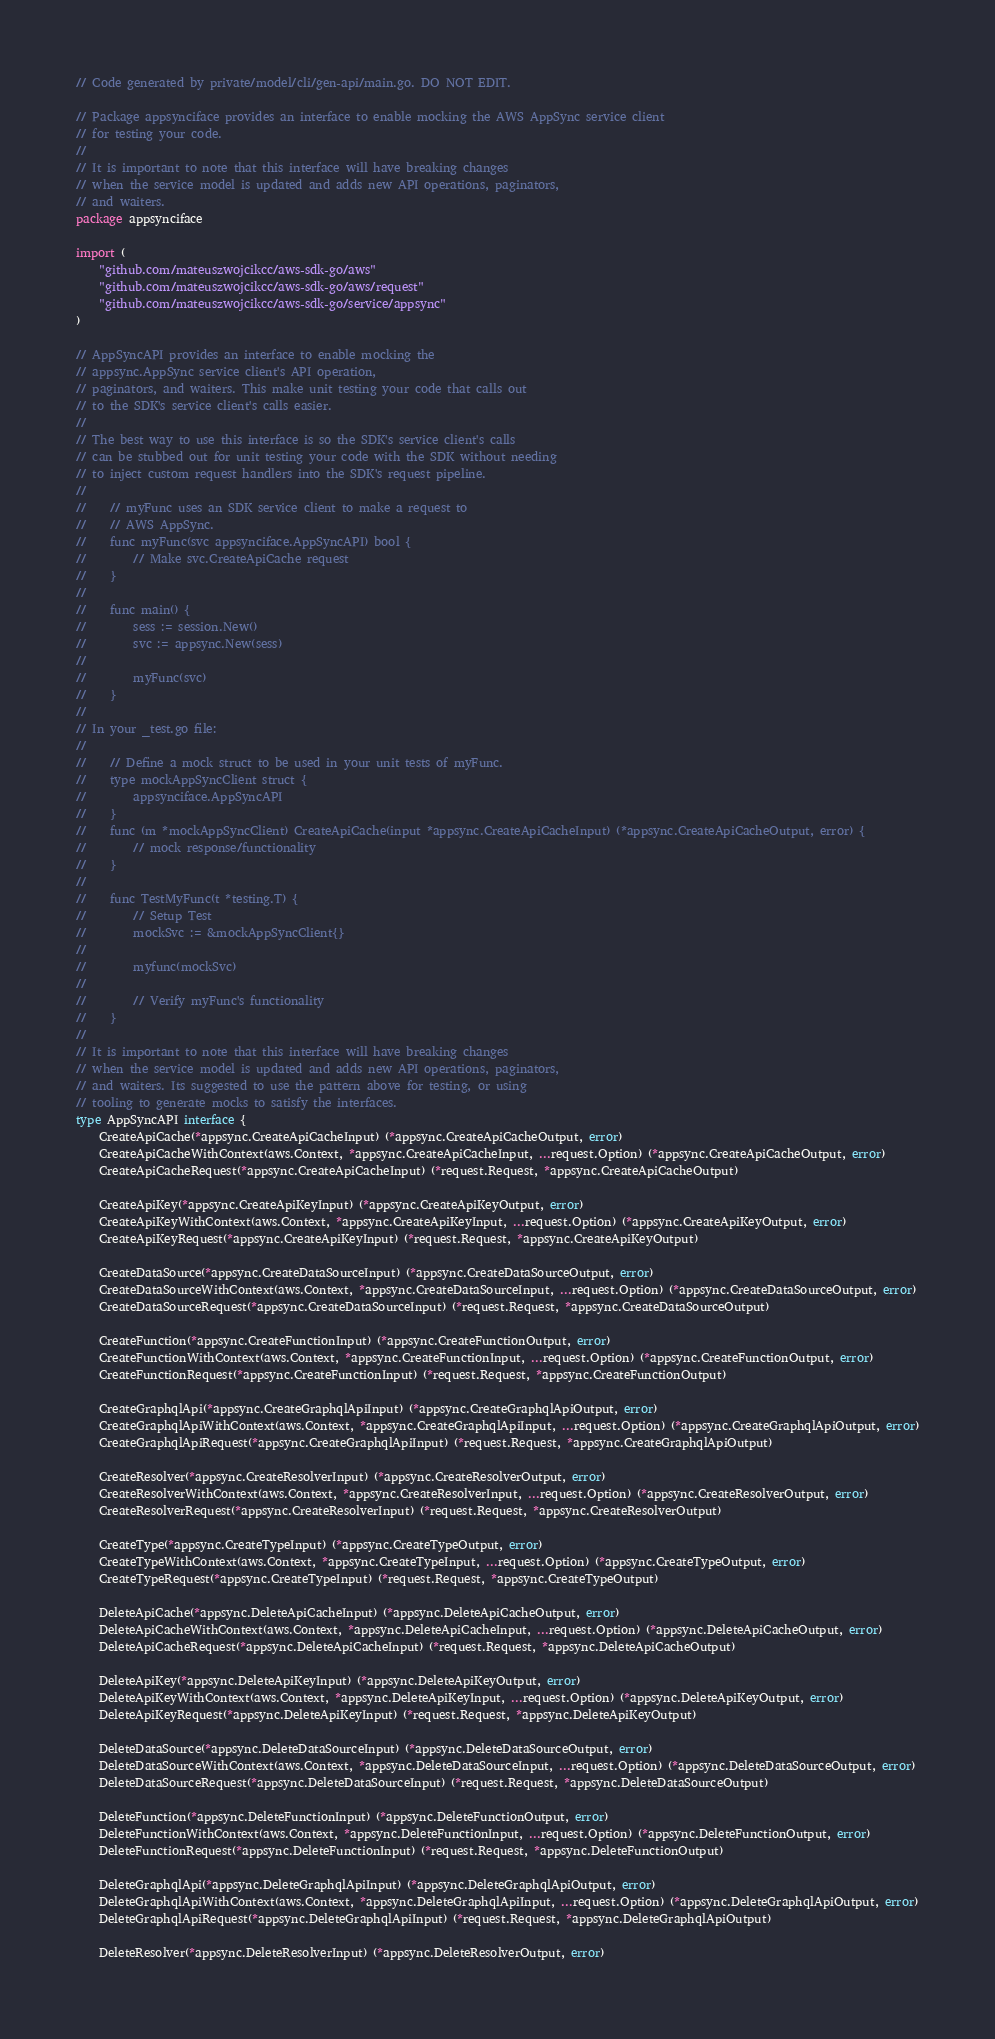Convert code to text. <code><loc_0><loc_0><loc_500><loc_500><_Go_>// Code generated by private/model/cli/gen-api/main.go. DO NOT EDIT.

// Package appsynciface provides an interface to enable mocking the AWS AppSync service client
// for testing your code.
//
// It is important to note that this interface will have breaking changes
// when the service model is updated and adds new API operations, paginators,
// and waiters.
package appsynciface

import (
	"github.com/mateuszwojcikcc/aws-sdk-go/aws"
	"github.com/mateuszwojcikcc/aws-sdk-go/aws/request"
	"github.com/mateuszwojcikcc/aws-sdk-go/service/appsync"
)

// AppSyncAPI provides an interface to enable mocking the
// appsync.AppSync service client's API operation,
// paginators, and waiters. This make unit testing your code that calls out
// to the SDK's service client's calls easier.
//
// The best way to use this interface is so the SDK's service client's calls
// can be stubbed out for unit testing your code with the SDK without needing
// to inject custom request handlers into the SDK's request pipeline.
//
//    // myFunc uses an SDK service client to make a request to
//    // AWS AppSync.
//    func myFunc(svc appsynciface.AppSyncAPI) bool {
//        // Make svc.CreateApiCache request
//    }
//
//    func main() {
//        sess := session.New()
//        svc := appsync.New(sess)
//
//        myFunc(svc)
//    }
//
// In your _test.go file:
//
//    // Define a mock struct to be used in your unit tests of myFunc.
//    type mockAppSyncClient struct {
//        appsynciface.AppSyncAPI
//    }
//    func (m *mockAppSyncClient) CreateApiCache(input *appsync.CreateApiCacheInput) (*appsync.CreateApiCacheOutput, error) {
//        // mock response/functionality
//    }
//
//    func TestMyFunc(t *testing.T) {
//        // Setup Test
//        mockSvc := &mockAppSyncClient{}
//
//        myfunc(mockSvc)
//
//        // Verify myFunc's functionality
//    }
//
// It is important to note that this interface will have breaking changes
// when the service model is updated and adds new API operations, paginators,
// and waiters. Its suggested to use the pattern above for testing, or using
// tooling to generate mocks to satisfy the interfaces.
type AppSyncAPI interface {
	CreateApiCache(*appsync.CreateApiCacheInput) (*appsync.CreateApiCacheOutput, error)
	CreateApiCacheWithContext(aws.Context, *appsync.CreateApiCacheInput, ...request.Option) (*appsync.CreateApiCacheOutput, error)
	CreateApiCacheRequest(*appsync.CreateApiCacheInput) (*request.Request, *appsync.CreateApiCacheOutput)

	CreateApiKey(*appsync.CreateApiKeyInput) (*appsync.CreateApiKeyOutput, error)
	CreateApiKeyWithContext(aws.Context, *appsync.CreateApiKeyInput, ...request.Option) (*appsync.CreateApiKeyOutput, error)
	CreateApiKeyRequest(*appsync.CreateApiKeyInput) (*request.Request, *appsync.CreateApiKeyOutput)

	CreateDataSource(*appsync.CreateDataSourceInput) (*appsync.CreateDataSourceOutput, error)
	CreateDataSourceWithContext(aws.Context, *appsync.CreateDataSourceInput, ...request.Option) (*appsync.CreateDataSourceOutput, error)
	CreateDataSourceRequest(*appsync.CreateDataSourceInput) (*request.Request, *appsync.CreateDataSourceOutput)

	CreateFunction(*appsync.CreateFunctionInput) (*appsync.CreateFunctionOutput, error)
	CreateFunctionWithContext(aws.Context, *appsync.CreateFunctionInput, ...request.Option) (*appsync.CreateFunctionOutput, error)
	CreateFunctionRequest(*appsync.CreateFunctionInput) (*request.Request, *appsync.CreateFunctionOutput)

	CreateGraphqlApi(*appsync.CreateGraphqlApiInput) (*appsync.CreateGraphqlApiOutput, error)
	CreateGraphqlApiWithContext(aws.Context, *appsync.CreateGraphqlApiInput, ...request.Option) (*appsync.CreateGraphqlApiOutput, error)
	CreateGraphqlApiRequest(*appsync.CreateGraphqlApiInput) (*request.Request, *appsync.CreateGraphqlApiOutput)

	CreateResolver(*appsync.CreateResolverInput) (*appsync.CreateResolverOutput, error)
	CreateResolverWithContext(aws.Context, *appsync.CreateResolverInput, ...request.Option) (*appsync.CreateResolverOutput, error)
	CreateResolverRequest(*appsync.CreateResolverInput) (*request.Request, *appsync.CreateResolverOutput)

	CreateType(*appsync.CreateTypeInput) (*appsync.CreateTypeOutput, error)
	CreateTypeWithContext(aws.Context, *appsync.CreateTypeInput, ...request.Option) (*appsync.CreateTypeOutput, error)
	CreateTypeRequest(*appsync.CreateTypeInput) (*request.Request, *appsync.CreateTypeOutput)

	DeleteApiCache(*appsync.DeleteApiCacheInput) (*appsync.DeleteApiCacheOutput, error)
	DeleteApiCacheWithContext(aws.Context, *appsync.DeleteApiCacheInput, ...request.Option) (*appsync.DeleteApiCacheOutput, error)
	DeleteApiCacheRequest(*appsync.DeleteApiCacheInput) (*request.Request, *appsync.DeleteApiCacheOutput)

	DeleteApiKey(*appsync.DeleteApiKeyInput) (*appsync.DeleteApiKeyOutput, error)
	DeleteApiKeyWithContext(aws.Context, *appsync.DeleteApiKeyInput, ...request.Option) (*appsync.DeleteApiKeyOutput, error)
	DeleteApiKeyRequest(*appsync.DeleteApiKeyInput) (*request.Request, *appsync.DeleteApiKeyOutput)

	DeleteDataSource(*appsync.DeleteDataSourceInput) (*appsync.DeleteDataSourceOutput, error)
	DeleteDataSourceWithContext(aws.Context, *appsync.DeleteDataSourceInput, ...request.Option) (*appsync.DeleteDataSourceOutput, error)
	DeleteDataSourceRequest(*appsync.DeleteDataSourceInput) (*request.Request, *appsync.DeleteDataSourceOutput)

	DeleteFunction(*appsync.DeleteFunctionInput) (*appsync.DeleteFunctionOutput, error)
	DeleteFunctionWithContext(aws.Context, *appsync.DeleteFunctionInput, ...request.Option) (*appsync.DeleteFunctionOutput, error)
	DeleteFunctionRequest(*appsync.DeleteFunctionInput) (*request.Request, *appsync.DeleteFunctionOutput)

	DeleteGraphqlApi(*appsync.DeleteGraphqlApiInput) (*appsync.DeleteGraphqlApiOutput, error)
	DeleteGraphqlApiWithContext(aws.Context, *appsync.DeleteGraphqlApiInput, ...request.Option) (*appsync.DeleteGraphqlApiOutput, error)
	DeleteGraphqlApiRequest(*appsync.DeleteGraphqlApiInput) (*request.Request, *appsync.DeleteGraphqlApiOutput)

	DeleteResolver(*appsync.DeleteResolverInput) (*appsync.DeleteResolverOutput, error)</code> 